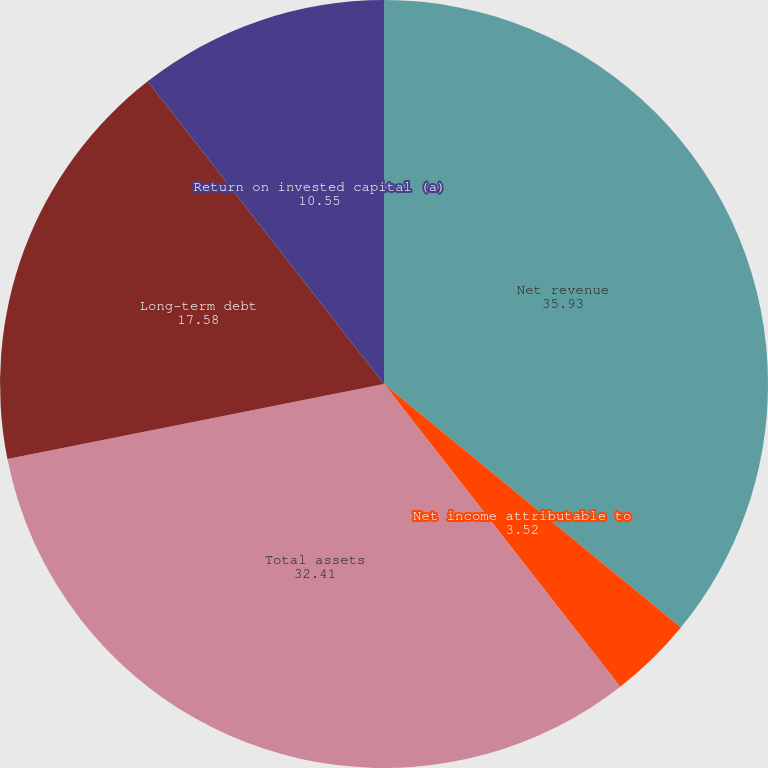Convert chart. <chart><loc_0><loc_0><loc_500><loc_500><pie_chart><fcel>Net revenue<fcel>Net income attributable to<fcel>Cash dividends declared per<fcel>Total assets<fcel>Long-term debt<fcel>Return on invested capital (a)<nl><fcel>35.93%<fcel>3.52%<fcel>0.0%<fcel>32.41%<fcel>17.58%<fcel>10.55%<nl></chart> 